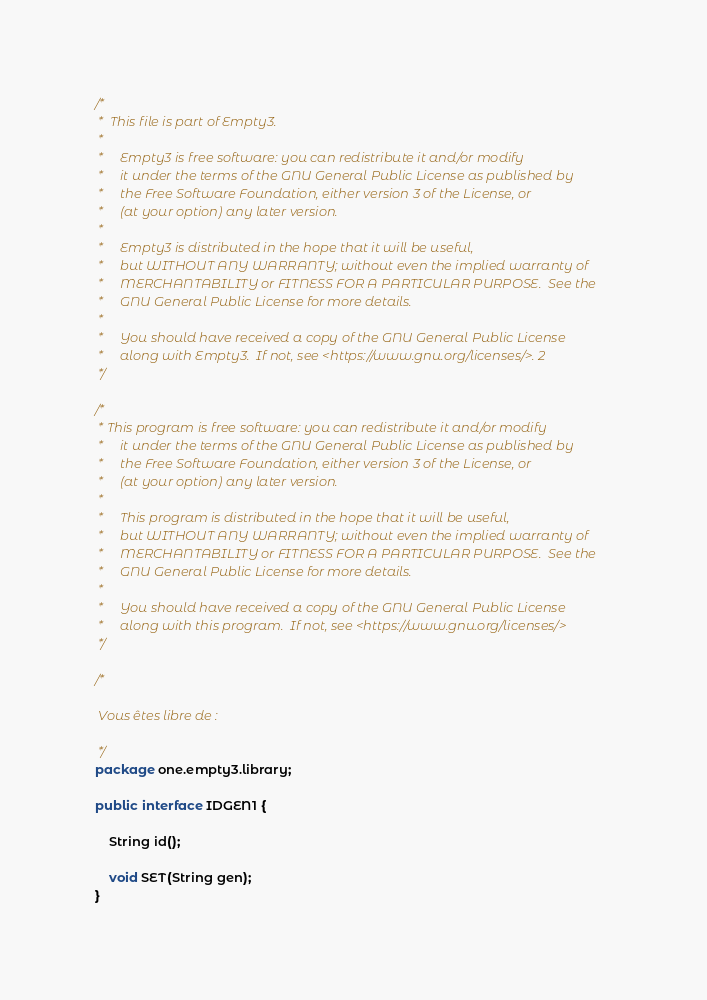Convert code to text. <code><loc_0><loc_0><loc_500><loc_500><_Java_>/*
 *  This file is part of Empty3.
 *
 *     Empty3 is free software: you can redistribute it and/or modify
 *     it under the terms of the GNU General Public License as published by
 *     the Free Software Foundation, either version 3 of the License, or
 *     (at your option) any later version.
 *
 *     Empty3 is distributed in the hope that it will be useful,
 *     but WITHOUT ANY WARRANTY; without even the implied warranty of
 *     MERCHANTABILITY or FITNESS FOR A PARTICULAR PURPOSE.  See the
 *     GNU General Public License for more details.
 *
 *     You should have received a copy of the GNU General Public License
 *     along with Empty3.  If not, see <https://www.gnu.org/licenses/>. 2
 */

/*
 * This program is free software: you can redistribute it and/or modify
 *     it under the terms of the GNU General Public License as published by
 *     the Free Software Foundation, either version 3 of the License, or
 *     (at your option) any later version.
 *
 *     This program is distributed in the hope that it will be useful,
 *     but WITHOUT ANY WARRANTY; without even the implied warranty of
 *     MERCHANTABILITY or FITNESS FOR A PARTICULAR PURPOSE.  See the
 *     GNU General Public License for more details.
 *
 *     You should have received a copy of the GNU General Public License
 *     along with this program.  If not, see <https://www.gnu.org/licenses/>
 */

/*

 Vous êtes libre de :

 */
package one.empty3.library;

public interface IDGEN1 {

    String id();

    void SET(String gen);
}
</code> 